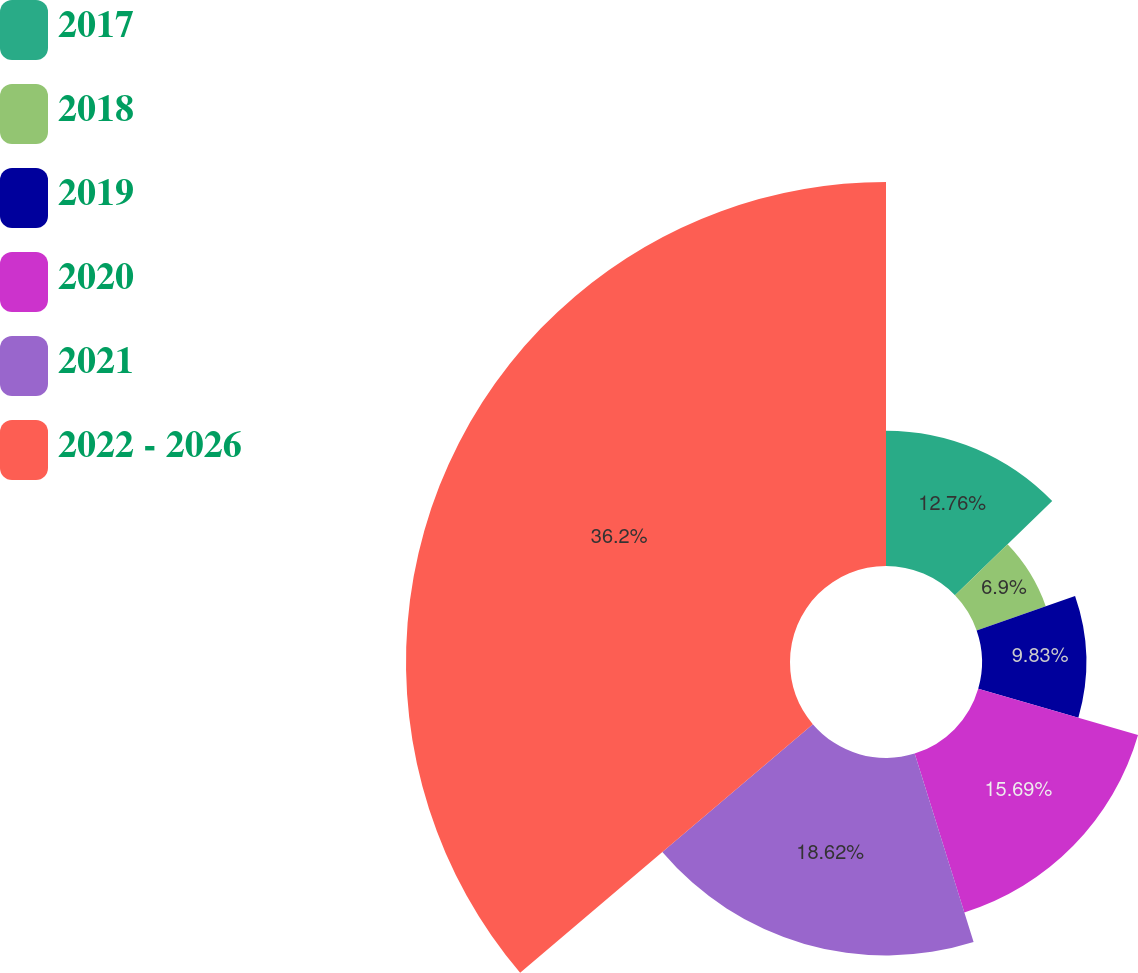Convert chart to OTSL. <chart><loc_0><loc_0><loc_500><loc_500><pie_chart><fcel>2017<fcel>2018<fcel>2019<fcel>2020<fcel>2021<fcel>2022 - 2026<nl><fcel>12.76%<fcel>6.9%<fcel>9.83%<fcel>15.69%<fcel>18.62%<fcel>36.21%<nl></chart> 